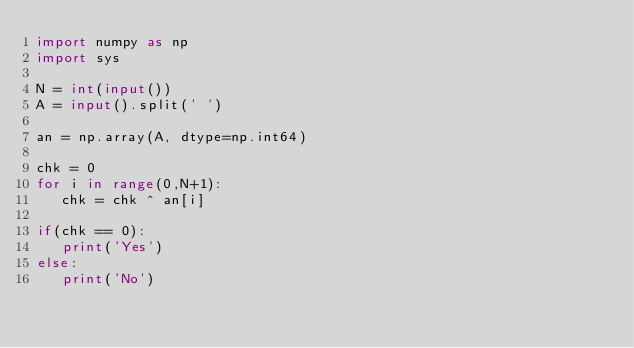<code> <loc_0><loc_0><loc_500><loc_500><_Python_>import numpy as np
import sys

N = int(input())
A = input().split(' ')

an = np.array(A, dtype=np.int64)

chk = 0
for i in range(0,N+1):
   chk = chk ^ an[i] 

if(chk == 0):
   print('Yes')
else:
   print('No')
  



</code> 